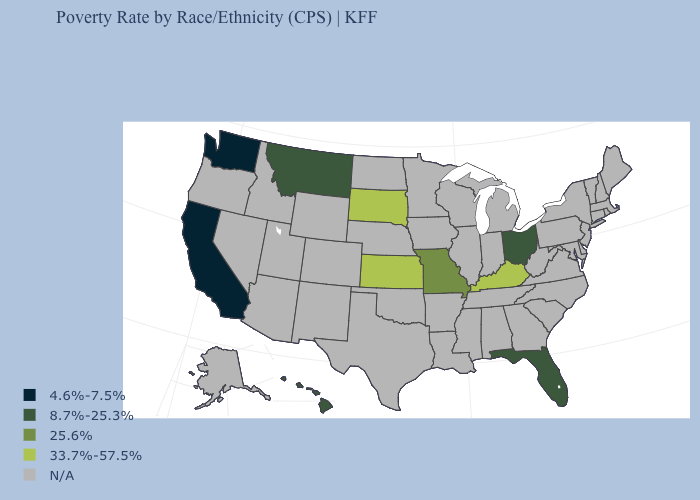Name the states that have a value in the range 4.6%-7.5%?
Give a very brief answer. California, Washington. Name the states that have a value in the range N/A?
Concise answer only. Alabama, Alaska, Arizona, Arkansas, Colorado, Connecticut, Delaware, Georgia, Idaho, Illinois, Indiana, Iowa, Louisiana, Maine, Maryland, Massachusetts, Michigan, Minnesota, Mississippi, Nebraska, Nevada, New Hampshire, New Jersey, New Mexico, New York, North Carolina, North Dakota, Oklahoma, Oregon, Pennsylvania, Rhode Island, South Carolina, Tennessee, Texas, Utah, Vermont, Virginia, West Virginia, Wisconsin, Wyoming. Does the map have missing data?
Answer briefly. Yes. Does the first symbol in the legend represent the smallest category?
Keep it brief. Yes. Which states have the lowest value in the USA?
Answer briefly. California, Washington. What is the highest value in the South ?
Keep it brief. 33.7%-57.5%. What is the lowest value in the South?
Be succinct. 8.7%-25.3%. What is the value of North Dakota?
Be succinct. N/A. Name the states that have a value in the range 33.7%-57.5%?
Answer briefly. Kansas, Kentucky, South Dakota. How many symbols are there in the legend?
Keep it brief. 5. What is the value of Pennsylvania?
Answer briefly. N/A. Which states have the lowest value in the MidWest?
Keep it brief. Ohio. Among the states that border Arkansas , which have the lowest value?
Answer briefly. Missouri. 